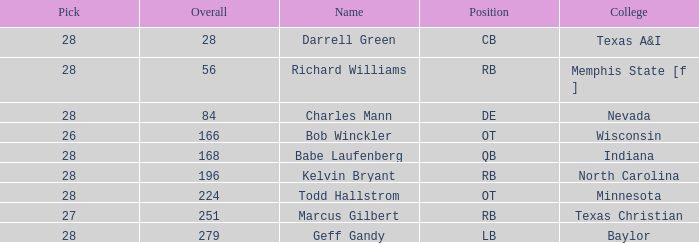What is the maximum draft choice of the player from texas a&i with an overall under 28? None. Write the full table. {'header': ['Pick', 'Overall', 'Name', 'Position', 'College'], 'rows': [['28', '28', 'Darrell Green', 'CB', 'Texas A&I'], ['28', '56', 'Richard Williams', 'RB', 'Memphis State [f ]'], ['28', '84', 'Charles Mann', 'DE', 'Nevada'], ['26', '166', 'Bob Winckler', 'OT', 'Wisconsin'], ['28', '168', 'Babe Laufenberg', 'QB', 'Indiana'], ['28', '196', 'Kelvin Bryant', 'RB', 'North Carolina'], ['28', '224', 'Todd Hallstrom', 'OT', 'Minnesota'], ['27', '251', 'Marcus Gilbert', 'RB', 'Texas Christian'], ['28', '279', 'Geff Gandy', 'LB', 'Baylor']]} 